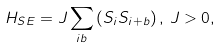<formula> <loc_0><loc_0><loc_500><loc_500>H _ { S E } = J \sum _ { i b } \left ( { S } _ { i } { S } _ { i + b } \right ) , \, J > 0 ,</formula> 